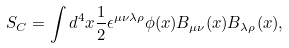Convert formula to latex. <formula><loc_0><loc_0><loc_500><loc_500>S _ { C } = \int d ^ { 4 } x \frac { 1 } { 2 } \epsilon ^ { \mu \nu \lambda \rho } \phi ( x ) B _ { \mu \nu } ( x ) B _ { \lambda \rho } ( x ) ,</formula> 